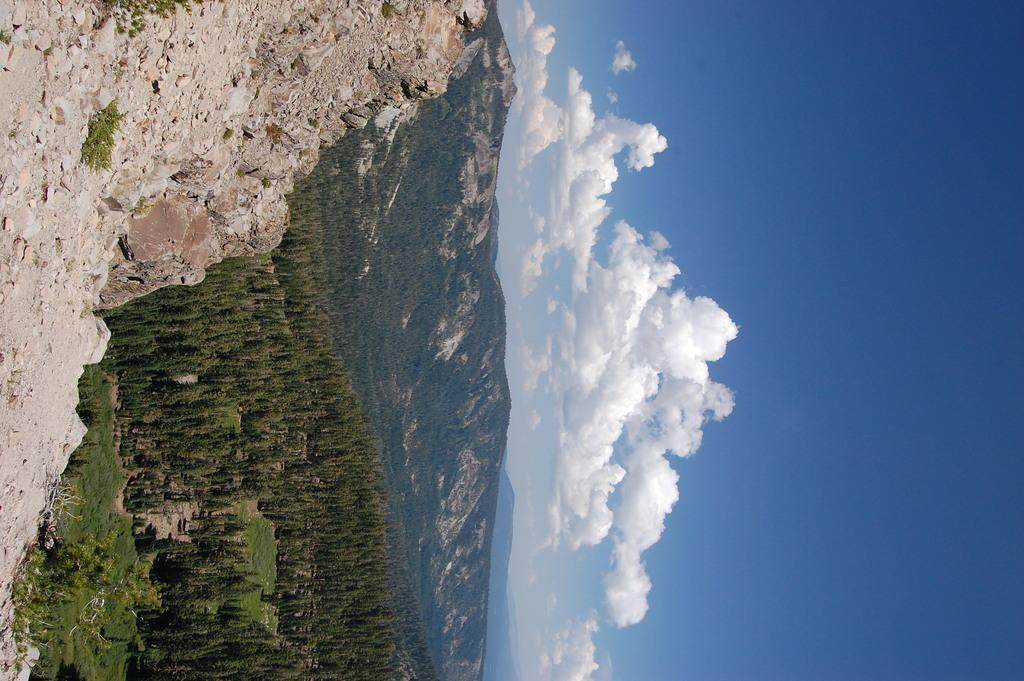What type of natural formations can be seen in the image? There are rocks, trees, and mountains in the image. What is visible in the background of the image? The sky is visible in the background of the image. What can be observed in the sky? Clouds are present in the sky. What type of roof can be seen on the mountains in the image? There are no roofs present on the mountains in the image, as mountains are natural formations and not structures with roofs. 